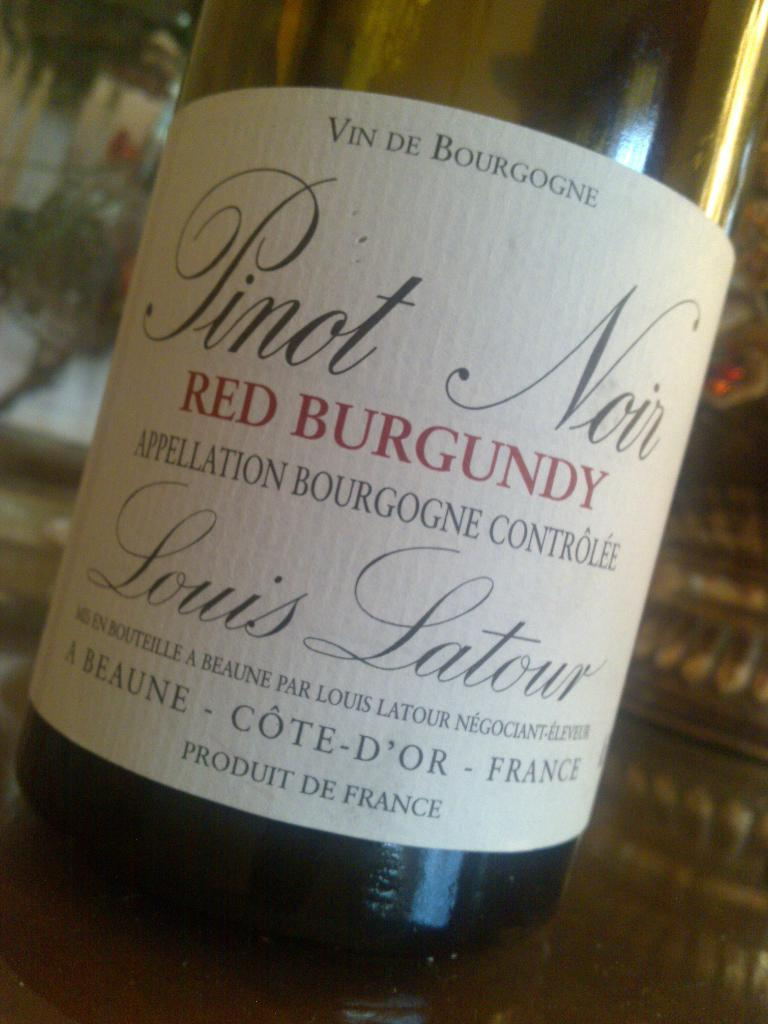<image>
Share a concise interpretation of the image provided. The bottle of wine is a red Pinot from France. 